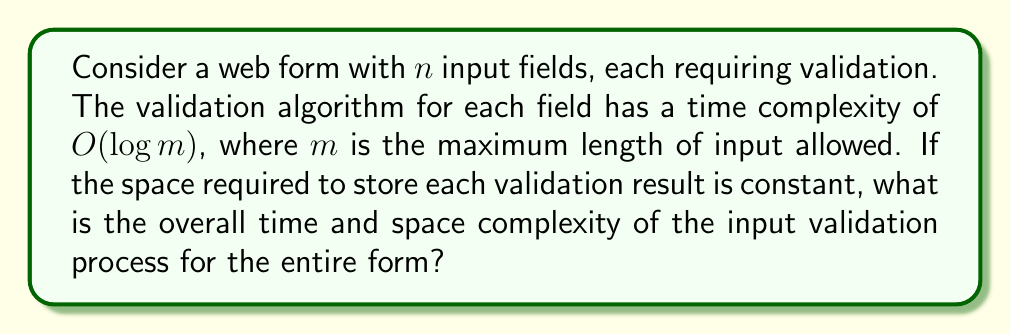Can you answer this question? To solve this problem, we need to consider both time and space complexity:

1. Time Complexity:
   - For each of the $n$ input fields, we perform a validation with complexity $O(\log m)$.
   - We need to do this for all $n$ fields.
   - Therefore, the total time complexity is $O(n \cdot \log m)$.

2. Space Complexity:
   - We're told that the space required to store each validation result is constant.
   - We have $n$ fields, each requiring constant space.
   - Thus, the space complexity is $O(n)$.

For a front-end designer implementing secure coding practices, understanding these complexities is crucial for optimizing form submission performance, especially for large forms or high-traffic websites.

The time complexity $O(n \cdot \log m)$ suggests that the validation time increases linearly with the number of fields and logarithmically with the maximum input length. This is generally efficient but could become a bottleneck for forms with many fields or very long input allowances.

The linear space complexity $O(n)$ indicates that memory usage scales directly with the number of fields, which is typically manageable for most web applications but should be considered for forms with an unusually high number of inputs.
Answer: Time Complexity: $O(n \cdot \log m)$
Space Complexity: $O(n)$
Where $n$ is the number of input fields and $m$ is the maximum length of input allowed. 